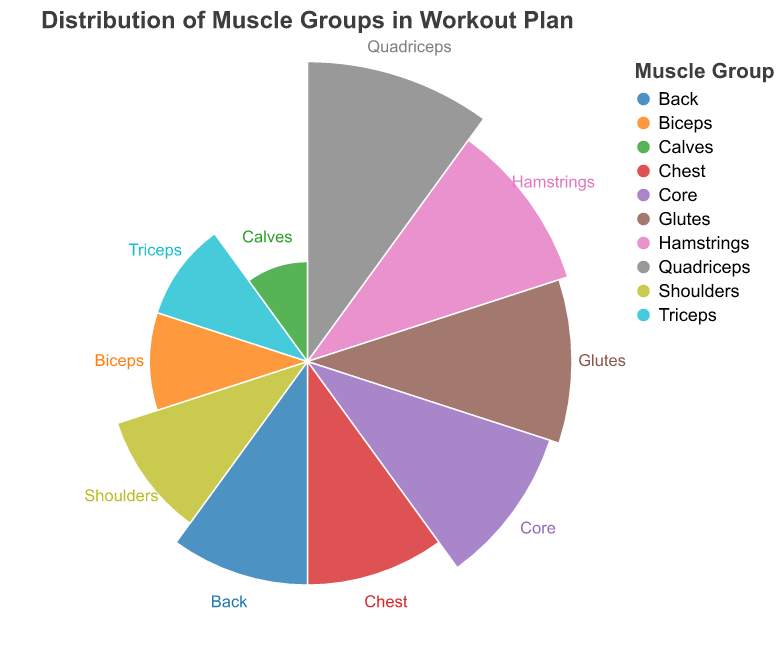What is the title of the chart? The title of the chart is generally found at the top and provides a summary of what the chart represents.
Answer: Distribution of Muscle Groups in Workout Plan Which muscle group is targeted the most in the workout plan? The largest portion of the chart represents the muscle group that is targeted the most.
Answer: Quadriceps What is the percentage for Core muscles? Look for the segment labeled "Core" and identify the corresponding percentage.
Answer: 13% Compare the percentages of Hamstrings and Glutes. Which one is larger? Locate both Hamstrings and Glutes on the chart and compare their percentages directly.
Answer: Hamstrings How many muscle groups are included in the workout plan? Count the distinct labels representing different muscle groups on the chart.
Answer: 10 What is the sum of the percentages for Chest, Back, and Shoulders? Identify and sum the percentages for Chest (10), Back (10), and Shoulders (8). The sum is 10 + 10 + 8.
Answer: 28% What muscle group has the smallest percentage? Look for the segment with the smallest value, which represents the smallest percentage.
Answer: Calves Which muscle groups have equal percentages? Find segments with equal values.
Answer: Biceps and Triceps What is the difference between the percentage of Quadriceps and Calves? Subtract the percentage for Calves (2%) from the percentage for Quadriceps (18%).
Answer: 16% How does the chart indicate the muscle group labels? The chart uses text labels positioned near each segment to indicate the corresponding muscle group.
Answer: Text labels near segments 